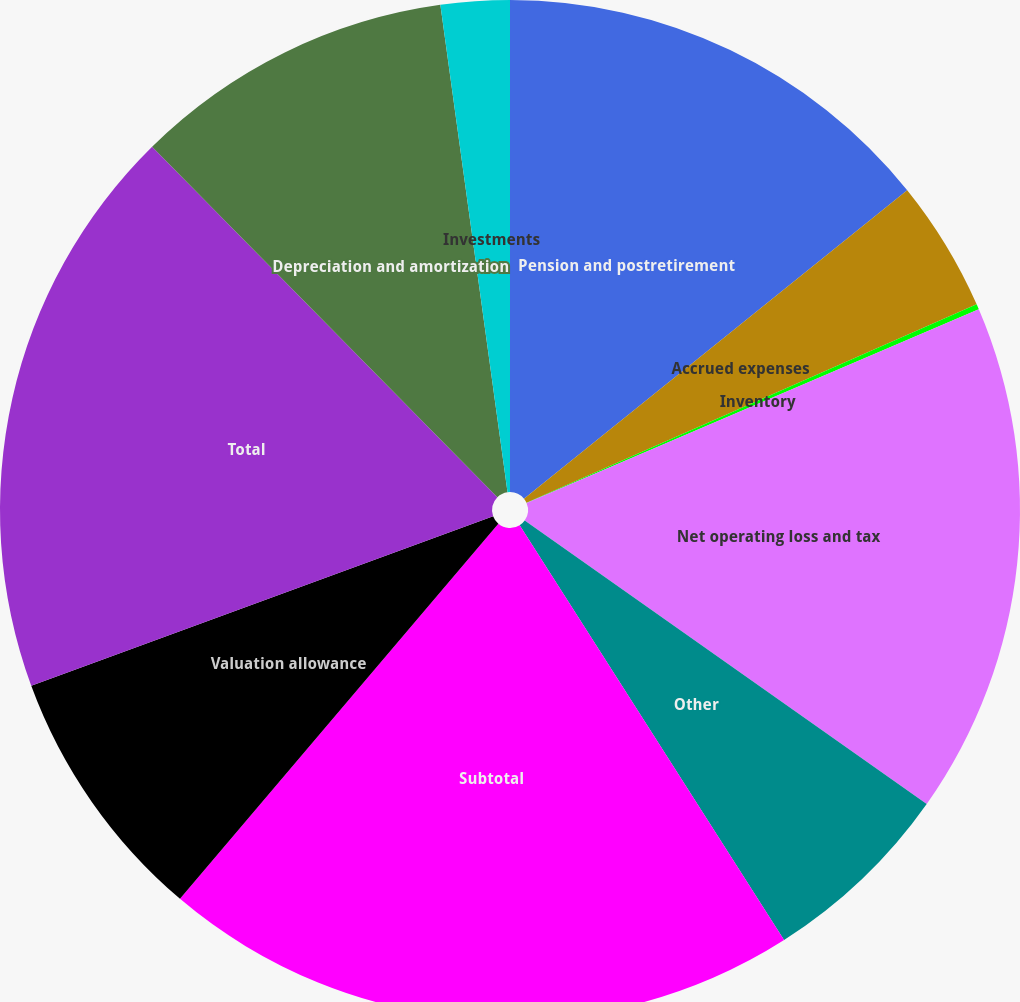Convert chart to OTSL. <chart><loc_0><loc_0><loc_500><loc_500><pie_chart><fcel>Pension and postretirement<fcel>Accrued expenses<fcel>Inventory<fcel>Net operating loss and tax<fcel>Other<fcel>Subtotal<fcel>Valuation allowance<fcel>Total<fcel>Depreciation and amortization<fcel>Investments<nl><fcel>14.21%<fcel>4.18%<fcel>0.17%<fcel>16.22%<fcel>6.19%<fcel>20.23%<fcel>8.2%<fcel>18.22%<fcel>10.2%<fcel>2.18%<nl></chart> 